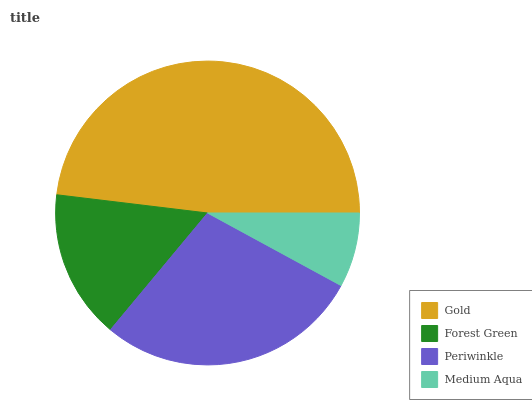Is Medium Aqua the minimum?
Answer yes or no. Yes. Is Gold the maximum?
Answer yes or no. Yes. Is Forest Green the minimum?
Answer yes or no. No. Is Forest Green the maximum?
Answer yes or no. No. Is Gold greater than Forest Green?
Answer yes or no. Yes. Is Forest Green less than Gold?
Answer yes or no. Yes. Is Forest Green greater than Gold?
Answer yes or no. No. Is Gold less than Forest Green?
Answer yes or no. No. Is Periwinkle the high median?
Answer yes or no. Yes. Is Forest Green the low median?
Answer yes or no. Yes. Is Gold the high median?
Answer yes or no. No. Is Periwinkle the low median?
Answer yes or no. No. 